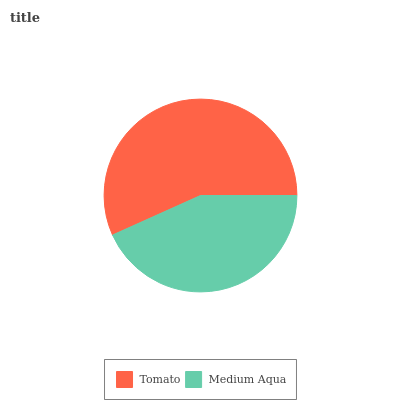Is Medium Aqua the minimum?
Answer yes or no. Yes. Is Tomato the maximum?
Answer yes or no. Yes. Is Medium Aqua the maximum?
Answer yes or no. No. Is Tomato greater than Medium Aqua?
Answer yes or no. Yes. Is Medium Aqua less than Tomato?
Answer yes or no. Yes. Is Medium Aqua greater than Tomato?
Answer yes or no. No. Is Tomato less than Medium Aqua?
Answer yes or no. No. Is Tomato the high median?
Answer yes or no. Yes. Is Medium Aqua the low median?
Answer yes or no. Yes. Is Medium Aqua the high median?
Answer yes or no. No. Is Tomato the low median?
Answer yes or no. No. 